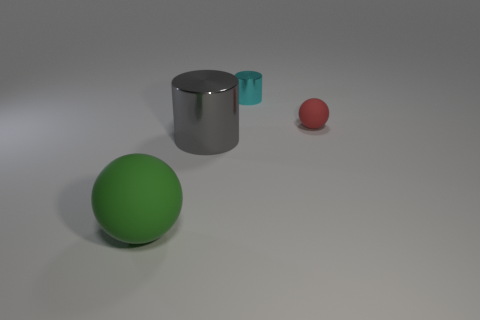What number of other things are there of the same shape as the gray thing?
Provide a short and direct response. 1. Is there anything else that is the same material as the red thing?
Make the answer very short. Yes. What color is the tiny thing to the right of the cylinder behind the small matte ball in front of the cyan metal object?
Your answer should be compact. Red. There is a metallic thing left of the tiny cyan metallic cylinder; is its shape the same as the small cyan thing?
Ensure brevity in your answer.  Yes. What number of things are there?
Give a very brief answer. 4. How many green rubber spheres have the same size as the cyan object?
Offer a terse response. 0. What is the large green ball made of?
Make the answer very short. Rubber. Does the tiny metallic object have the same color as the thing to the right of the tiny cyan thing?
Make the answer very short. No. Are there any other things that have the same size as the gray shiny object?
Provide a short and direct response. Yes. How big is the object that is both in front of the cyan shiny object and behind the gray cylinder?
Provide a succinct answer. Small. 